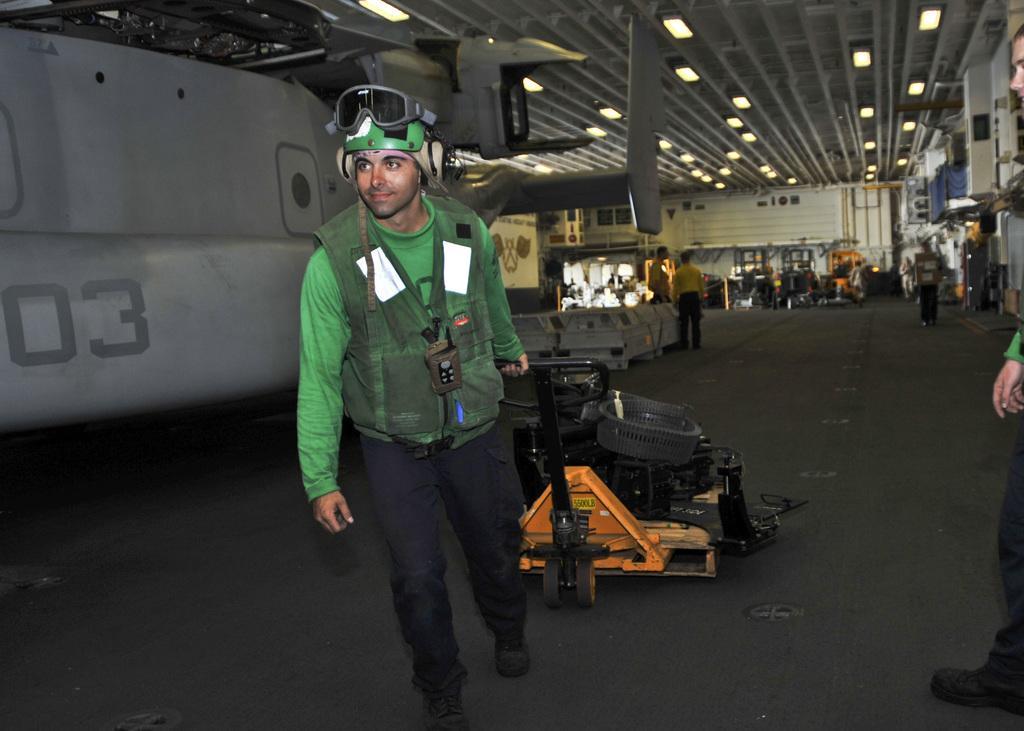In one or two sentences, can you explain what this image depicts? In the center of the image we can see a man standing and holding a trolley. In the background there are people and we can see some equipment. At the top there are lights. 